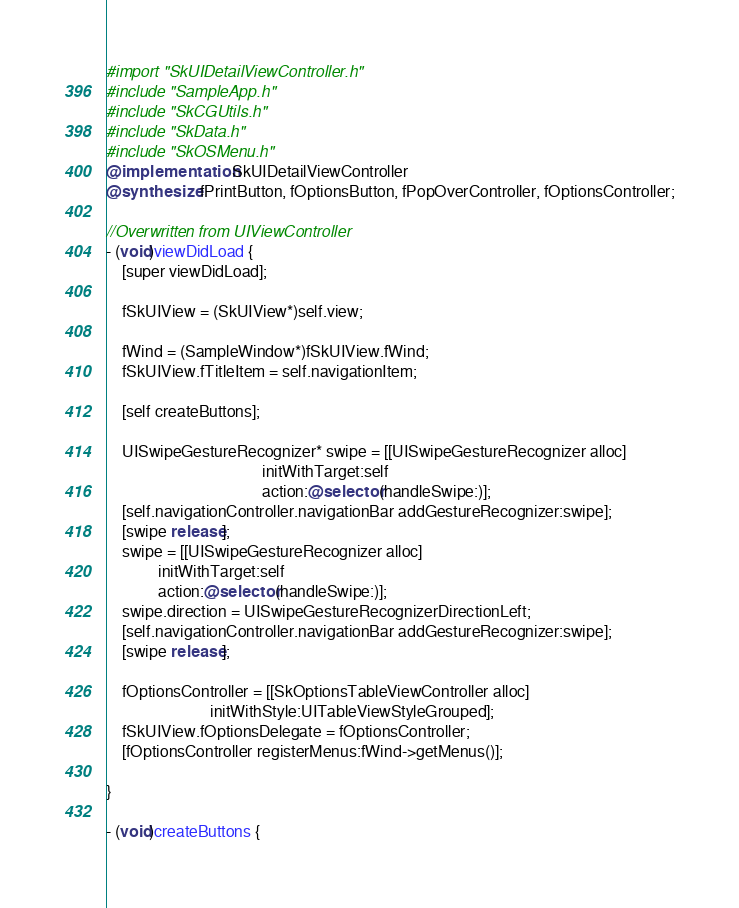<code> <loc_0><loc_0><loc_500><loc_500><_ObjectiveC_>#import "SkUIDetailViewController.h"
#include "SampleApp.h"
#include "SkCGUtils.h"
#include "SkData.h"
#include "SkOSMenu.h"
@implementation SkUIDetailViewController
@synthesize fPrintButton, fOptionsButton, fPopOverController, fOptionsController;

//Overwritten from UIViewController
- (void)viewDidLoad {
    [super viewDidLoad];

    fSkUIView = (SkUIView*)self.view;
    
    fWind = (SampleWindow*)fSkUIView.fWind;
    fSkUIView.fTitleItem = self.navigationItem;
    
    [self createButtons];
    
    UISwipeGestureRecognizer* swipe = [[UISwipeGestureRecognizer alloc]
                                       initWithTarget:self 
                                       action:@selector(handleSwipe:)];
    [self.navigationController.navigationBar addGestureRecognizer:swipe];
    [swipe release];
    swipe = [[UISwipeGestureRecognizer alloc]
             initWithTarget:self 
             action:@selector(handleSwipe:)];
    swipe.direction = UISwipeGestureRecognizerDirectionLeft;
    [self.navigationController.navigationBar addGestureRecognizer:swipe];
    [swipe release];
    
    fOptionsController = [[SkOptionsTableViewController alloc] 
                          initWithStyle:UITableViewStyleGrouped];
    fSkUIView.fOptionsDelegate = fOptionsController;
    [fOptionsController registerMenus:fWind->getMenus()];
    
}

- (void)createButtons {</code> 